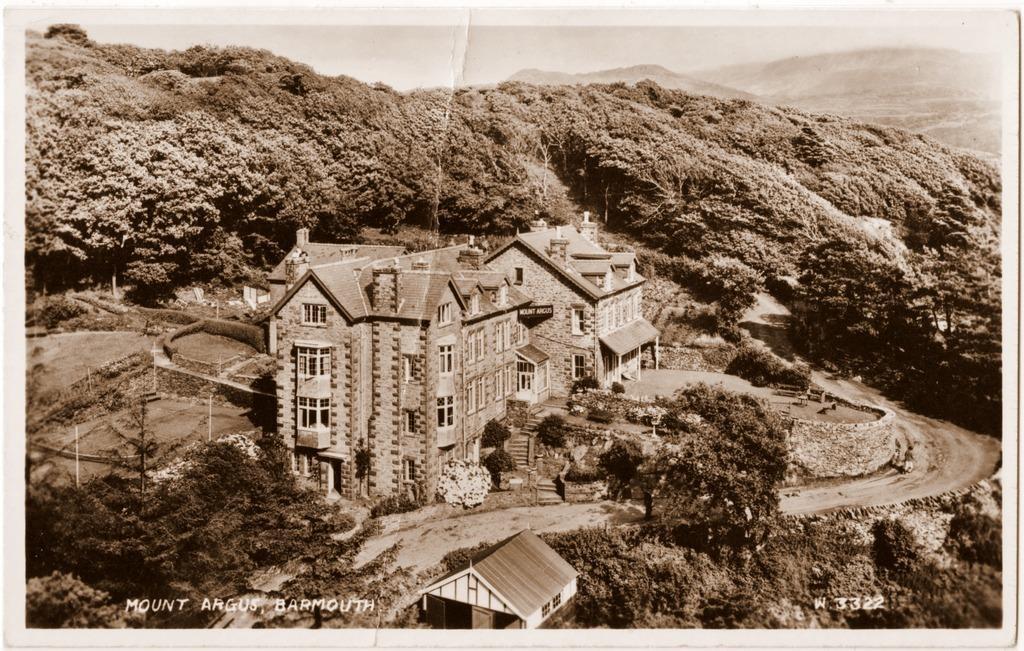In one or two sentences, can you explain what this image depicts? In this picture we can see the hills, trees and we can see the buildings, poles, pathway. At the bottom portion of the picture we can see a house and watermarks. 